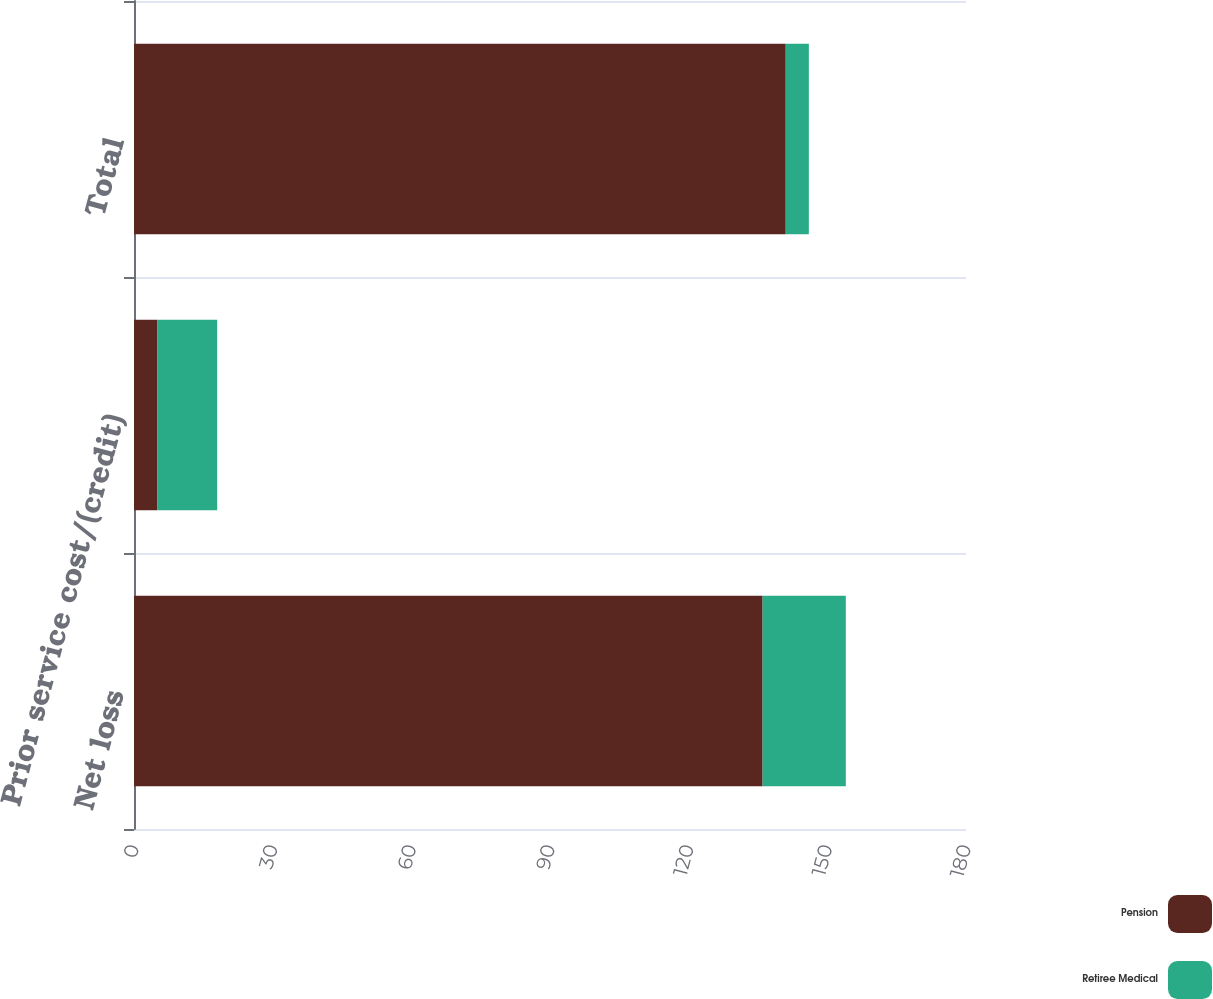Convert chart to OTSL. <chart><loc_0><loc_0><loc_500><loc_500><stacked_bar_chart><ecel><fcel>Net loss<fcel>Prior service cost/(credit)<fcel>Total<nl><fcel>Pension<fcel>136<fcel>5<fcel>141<nl><fcel>Retiree Medical<fcel>18<fcel>13<fcel>5<nl></chart> 